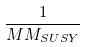Convert formula to latex. <formula><loc_0><loc_0><loc_500><loc_500>\frac { 1 } { M M _ { S U S Y } }</formula> 